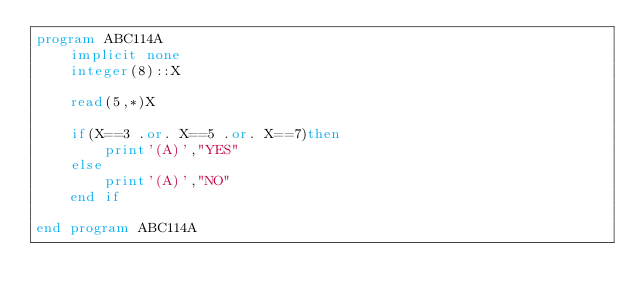Convert code to text. <code><loc_0><loc_0><loc_500><loc_500><_FORTRAN_>program ABC114A
    implicit none
    integer(8)::X

    read(5,*)X

    if(X==3 .or. X==5 .or. X==7)then
        print'(A)',"YES"
    else
        print'(A)',"NO"
    end if
    
end program ABC114A</code> 